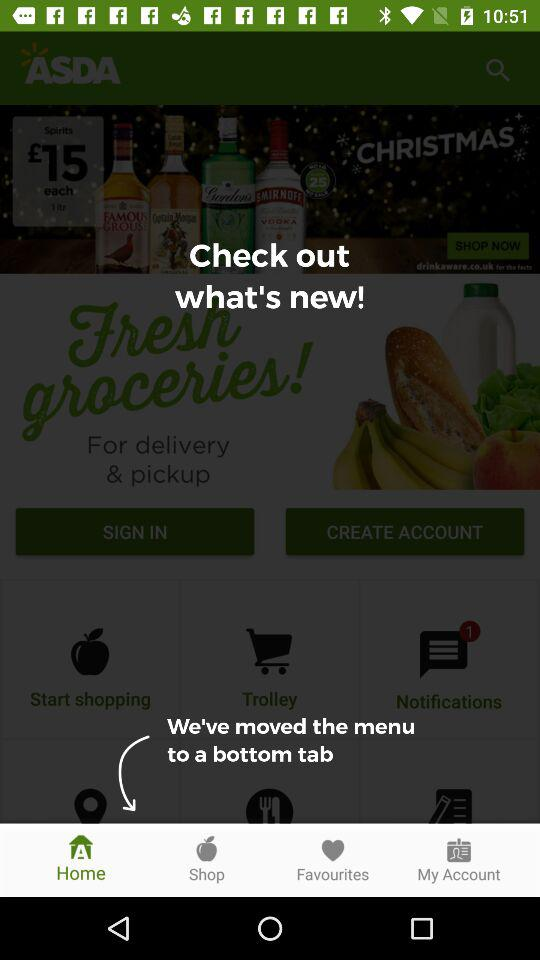Which items are listed in "Favourites"?
When the provided information is insufficient, respond with <no answer>. <no answer> 